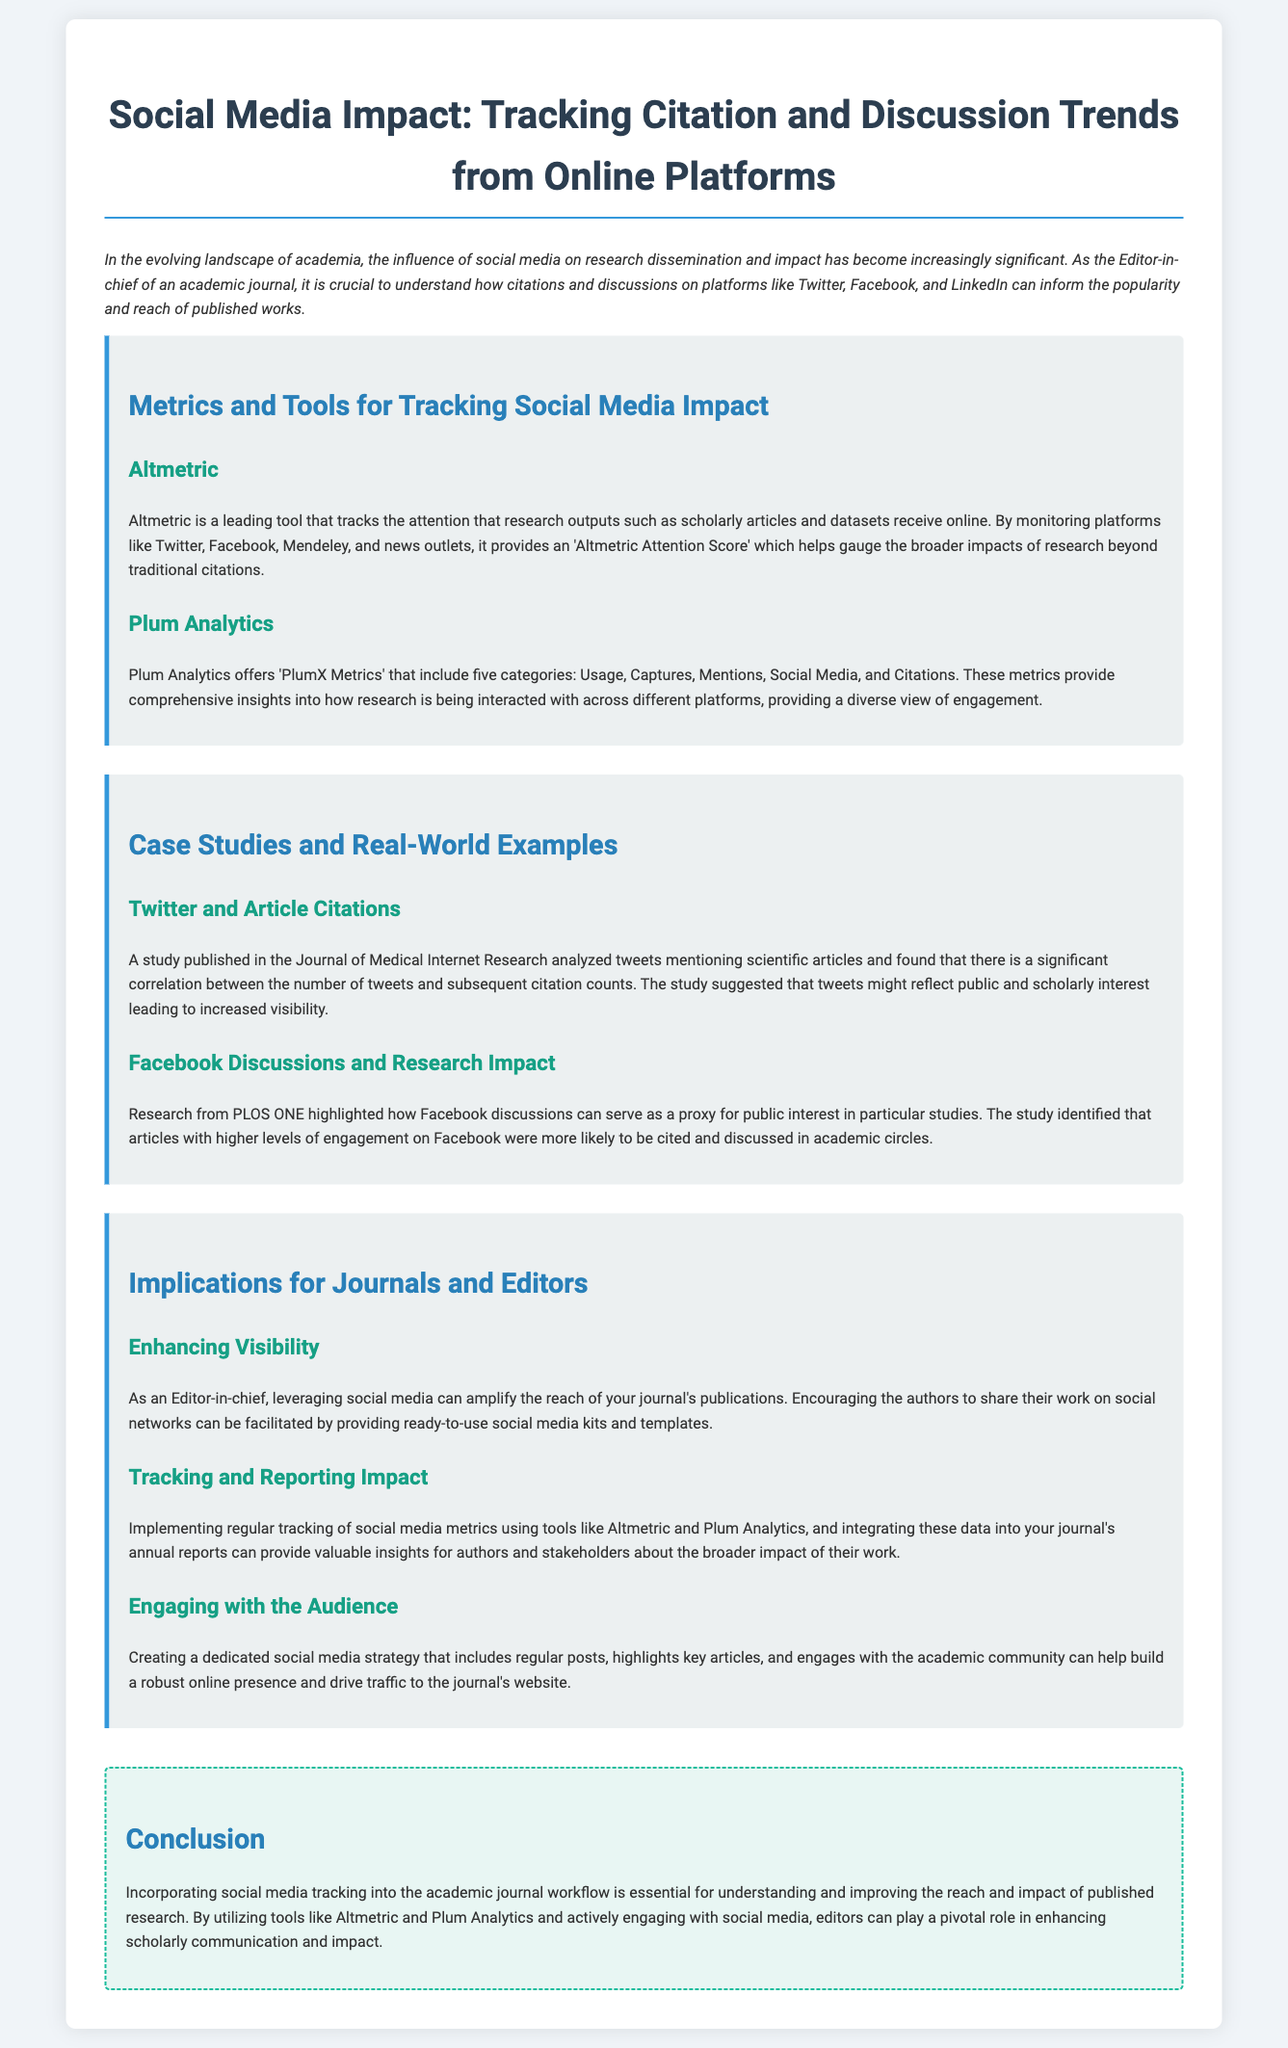what is the title of the report? The title is provided at the top of the document, summarizing the main focus of the report.
Answer: Social Media Impact: Tracking Citation and Discussion Trends from Online Platforms what is the primary tool mentioned for tracking social media impact? The document specifically mentions a tool that is widely recognized for monitoring research attention on various platforms.
Answer: Altmetric how many categories are included in Plum Analytics metrics? The document states that Plum Analytics offers metrics categorized into five specific types, indicating the breadth of their analysis.
Answer: Five which journal published the study on Twitter and article citations? The document references a specific journal that conducted research correlating tweets to citation counts, identifying its impact on visibility.
Answer: Journal of Medical Internet Research what is one implication for journals discussed in the report? The document outlines a strategy that editors can implement to enhance publication visibility through social engagement.
Answer: Enhancing Visibility what is the outcome of articles with higher Facebook engagement according to the report? The report mentions a direct correlation between Facebook discussions and academic interest, highlighting an effect on citation behavior.
Answer: More likely to be cited what should editors implement to track social media metrics? The document suggests an action that editors should take to monitor impacts effectively over time, which involves a specific type of analytics tool.
Answer: Regular tracking what is the color of the conclusion section? The report's conclusion is presented with a specified background color that enhances its visual distinction.
Answer: Light green 